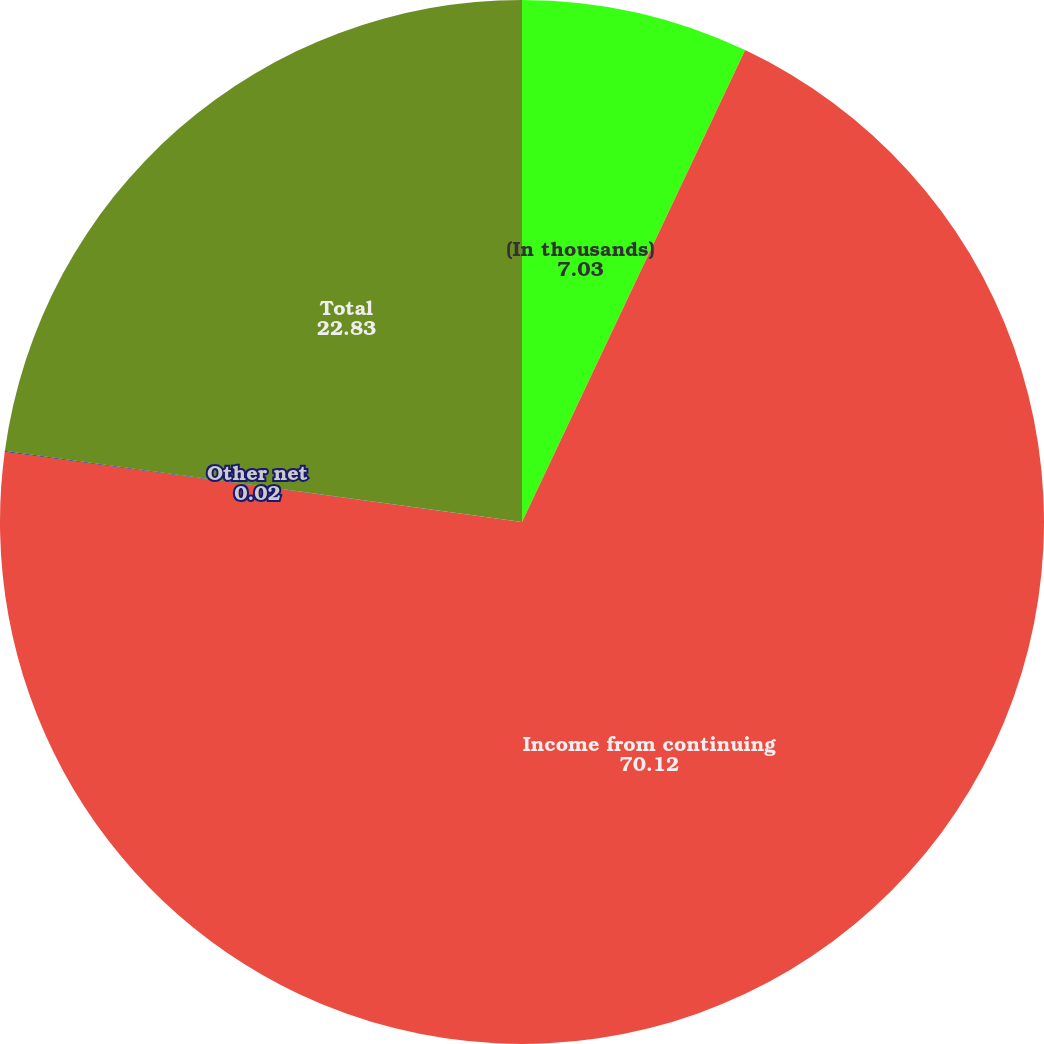<chart> <loc_0><loc_0><loc_500><loc_500><pie_chart><fcel>(In thousands)<fcel>Income from continuing<fcel>Other net<fcel>Total<nl><fcel>7.03%<fcel>70.12%<fcel>0.02%<fcel>22.83%<nl></chart> 